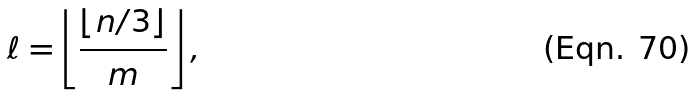<formula> <loc_0><loc_0><loc_500><loc_500>\ell = \left \lfloor \frac { \lfloor n / 3 \rfloor } { m } \right \rfloor ,</formula> 